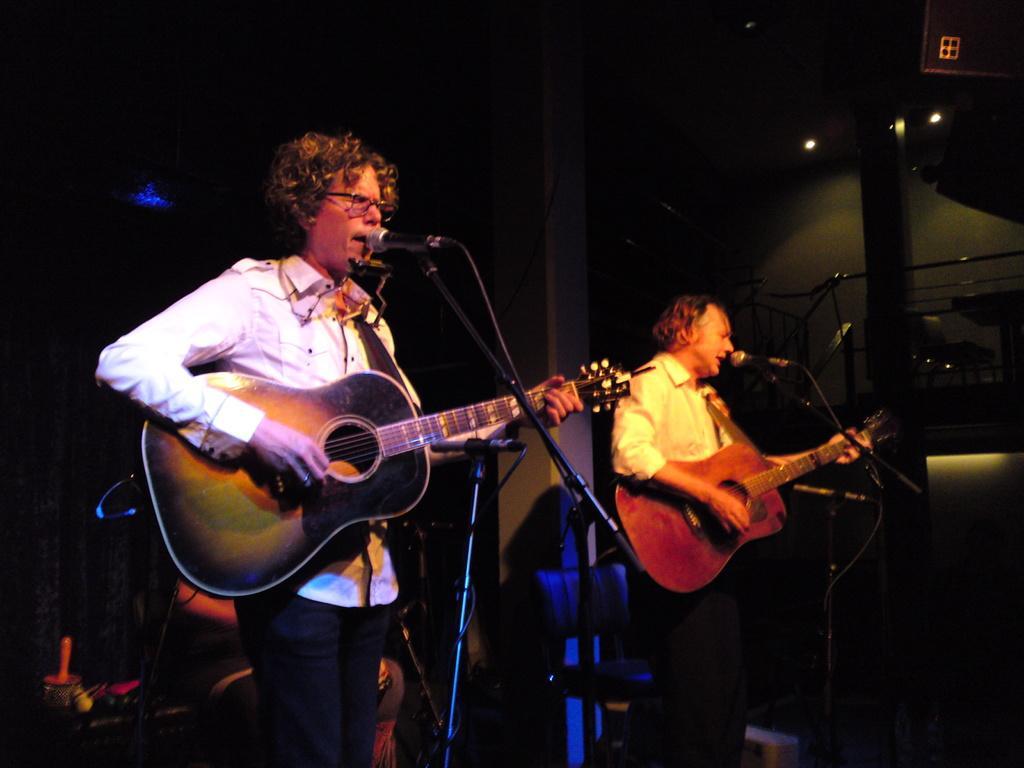Could you give a brief overview of what you see in this image? In this image I can see two persons wearing shirt, standing and holding guitars in their hands and also playing it. In front these people there is a mike. It seems to be like they are singing a song. In the background I can a chair. And it seems to be a dark room. 